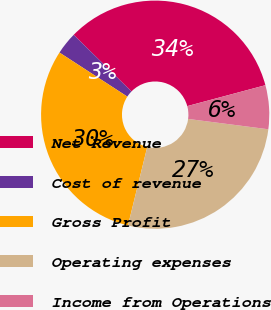Convert chart to OTSL. <chart><loc_0><loc_0><loc_500><loc_500><pie_chart><fcel>Net Revenue<fcel>Cost of revenue<fcel>Gross Profit<fcel>Operating expenses<fcel>Income from Operations<nl><fcel>33.5%<fcel>3.17%<fcel>30.33%<fcel>26.79%<fcel>6.2%<nl></chart> 